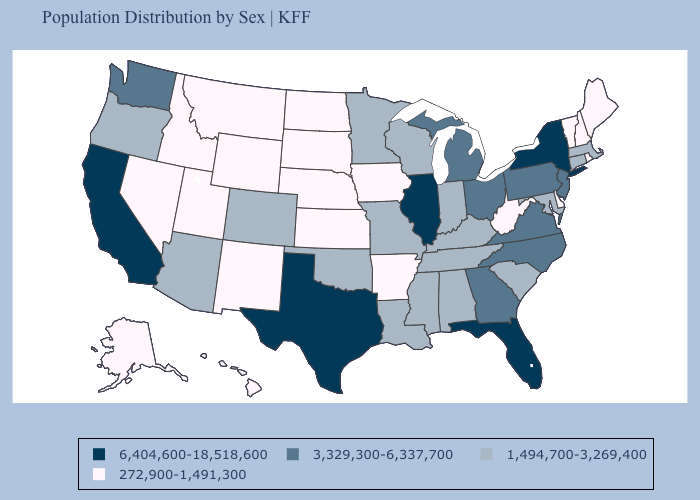Does Michigan have a lower value than Oregon?
Concise answer only. No. What is the highest value in the USA?
Be succinct. 6,404,600-18,518,600. Name the states that have a value in the range 272,900-1,491,300?
Concise answer only. Alaska, Arkansas, Delaware, Hawaii, Idaho, Iowa, Kansas, Maine, Montana, Nebraska, Nevada, New Hampshire, New Mexico, North Dakota, Rhode Island, South Dakota, Utah, Vermont, West Virginia, Wyoming. Which states have the lowest value in the USA?
Answer briefly. Alaska, Arkansas, Delaware, Hawaii, Idaho, Iowa, Kansas, Maine, Montana, Nebraska, Nevada, New Hampshire, New Mexico, North Dakota, Rhode Island, South Dakota, Utah, Vermont, West Virginia, Wyoming. Does Louisiana have the highest value in the USA?
Short answer required. No. Does Georgia have a lower value than North Carolina?
Short answer required. No. Name the states that have a value in the range 272,900-1,491,300?
Write a very short answer. Alaska, Arkansas, Delaware, Hawaii, Idaho, Iowa, Kansas, Maine, Montana, Nebraska, Nevada, New Hampshire, New Mexico, North Dakota, Rhode Island, South Dakota, Utah, Vermont, West Virginia, Wyoming. How many symbols are there in the legend?
Short answer required. 4. Name the states that have a value in the range 1,494,700-3,269,400?
Short answer required. Alabama, Arizona, Colorado, Connecticut, Indiana, Kentucky, Louisiana, Maryland, Massachusetts, Minnesota, Mississippi, Missouri, Oklahoma, Oregon, South Carolina, Tennessee, Wisconsin. What is the value of Indiana?
Give a very brief answer. 1,494,700-3,269,400. Does Nebraska have the lowest value in the USA?
Be succinct. Yes. What is the value of Idaho?
Keep it brief. 272,900-1,491,300. Name the states that have a value in the range 3,329,300-6,337,700?
Answer briefly. Georgia, Michigan, New Jersey, North Carolina, Ohio, Pennsylvania, Virginia, Washington. What is the value of Wisconsin?
Write a very short answer. 1,494,700-3,269,400. Name the states that have a value in the range 6,404,600-18,518,600?
Write a very short answer. California, Florida, Illinois, New York, Texas. 